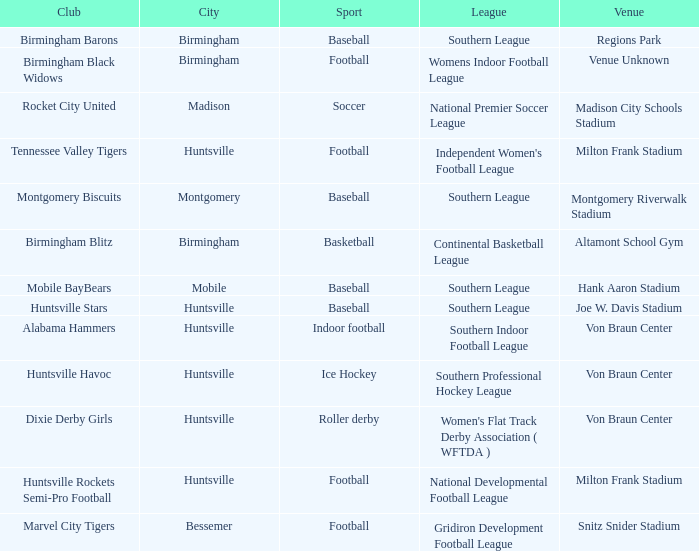Which venue hosted the Gridiron Development Football League? Snitz Snider Stadium. 